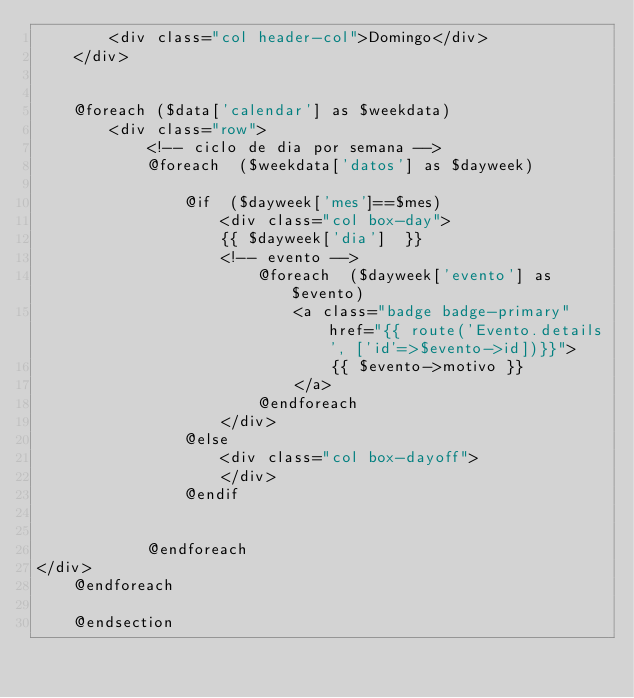Convert code to text. <code><loc_0><loc_0><loc_500><loc_500><_PHP_>        <div class="col header-col">Domingo</div>
    </div>


    @foreach ($data['calendar'] as $weekdata)
        <div class="row">
            <!-- ciclo de dia por semana -->
            @foreach  ($weekdata['datos'] as $dayweek)

                @if  ($dayweek['mes']==$mes)
                    <div class="col box-day">
                    {{ $dayweek['dia']  }}
                    <!-- evento -->
                        @foreach  ($dayweek['evento'] as $evento)
                            <a class="badge badge-primary" href="{{ route('Evento.details', ['id'=>$evento->id])}}">
                                {{ $evento->motivo }}
                            </a>
                        @endforeach
                    </div>
                @else
                    <div class="col box-dayoff">
                    </div>
                @endif


            @endforeach
</div>
    @endforeach

    @endsection</code> 